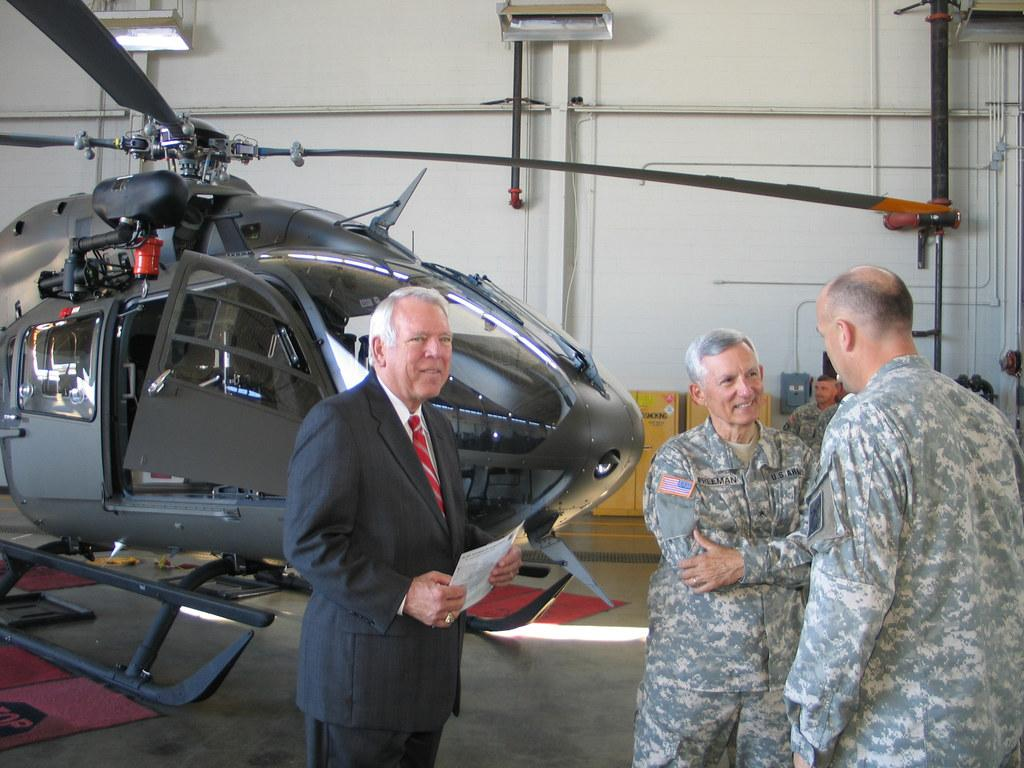How many people are in the foreground of the image? There are three persons standing in the foreground of the image. What is located behind the persons? There is a helicopter behind the persons. What can be seen in the background of the image? There is a wall in the background of the image. How many chairs are visible in the image? There are no chairs visible in the image. What is the cook doing in the image? There is no cook present in the image. 